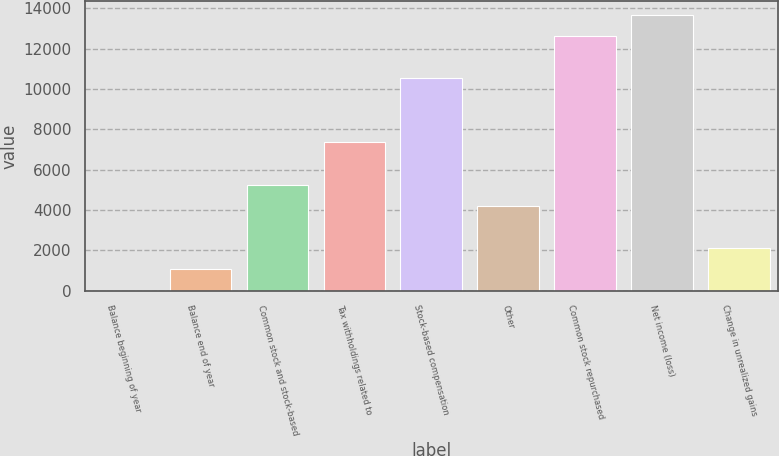Convert chart to OTSL. <chart><loc_0><loc_0><loc_500><loc_500><bar_chart><fcel>Balance beginning of year<fcel>Balance end of year<fcel>Common stock and stock-based<fcel>Tax withholdings related to<fcel>Stock-based compensation<fcel>Other<fcel>Common stock repurchased<fcel>Net income (loss)<fcel>Change in unrealized gains<nl><fcel>2<fcel>1054.4<fcel>5264<fcel>7368.8<fcel>10526<fcel>4211.6<fcel>12630.8<fcel>13683.2<fcel>2106.8<nl></chart> 